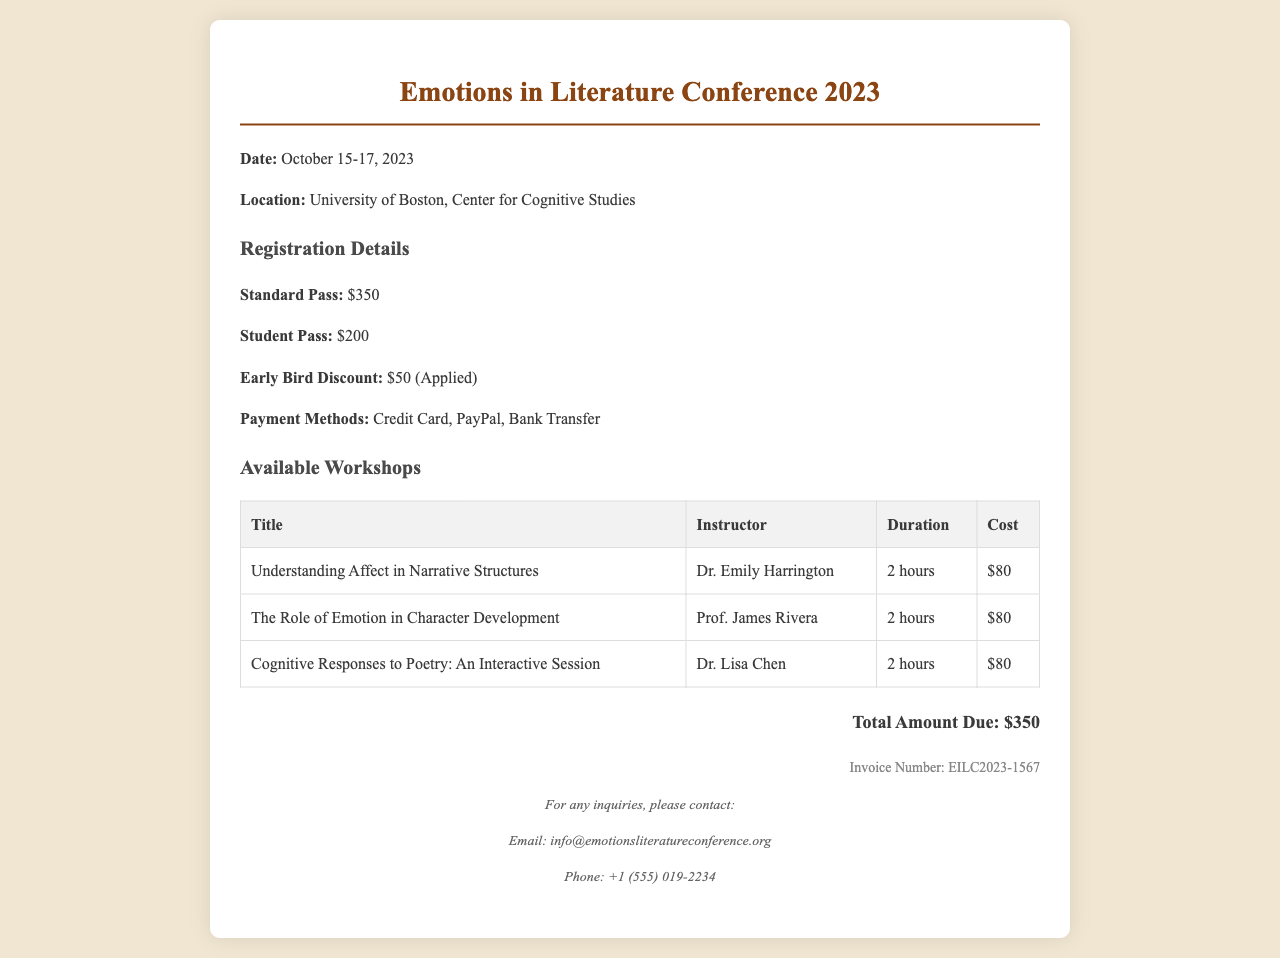What are the dates of the conference? The dates are specifically mentioned in the document as October 15-17, 2023.
Answer: October 15-17, 2023 What is the location of the event? The document clearly states that the conference is located at the University of Boston, Center for Cognitive Studies.
Answer: University of Boston, Center for Cognitive Studies What is the cost of a Standard Pass? The cost for a Standard Pass is specifically listed in the registration details as $350.
Answer: $350 How much is the Early Bird Discount? The document mentions an Early Bird Discount of $50 being applied.
Answer: $50 Who is the instructor for the workshop titled "Understanding Affect in Narrative Structures"? The table in the workshops section lists Dr. Emily Harrington as the instructor for that workshop.
Answer: Dr. Emily Harrington What is the total amount due for the registration? The receipt indicates the total amount due as $350, summarizing your registration cost.
Answer: $350 What payment methods are available? The registration details section specifies the available payment methods are Credit Card, PayPal, and Bank Transfer.
Answer: Credit Card, PayPal, Bank Transfer What is the invoice number for this receipt? The document provides the invoice number as EILC2023-1567 for reference.
Answer: EILC2023-1567 How many workshops are listed in the document? There are three workshops listed in the workshops section of the receipt.
Answer: Three 